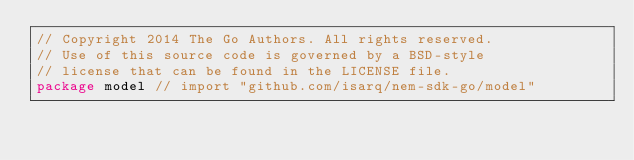Convert code to text. <code><loc_0><loc_0><loc_500><loc_500><_Go_>// Copyright 2014 The Go Authors. All rights reserved.
// Use of this source code is governed by a BSD-style
// license that can be found in the LICENSE file.
package model // import "github.com/isarq/nem-sdk-go/model"
</code> 